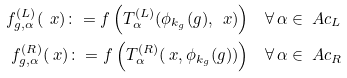Convert formula to latex. <formula><loc_0><loc_0><loc_500><loc_500>f ^ { ( L ) } _ { g , \alpha } ( \ x ) \colon = f \left ( T ^ { ( L ) } _ { \alpha } ( \phi _ { k _ { g } } ( g ) , \ x ) \right ) & \quad \forall \, \alpha \in \ A c _ { L } \\ f ^ { ( R ) } _ { g , \alpha } ( \ x ) \colon = f \left ( T ^ { ( R ) } _ { \alpha } ( \ x , \phi _ { k _ { g } } ( g ) ) \right ) & \quad \forall \, \alpha \in \ A c _ { R }</formula> 